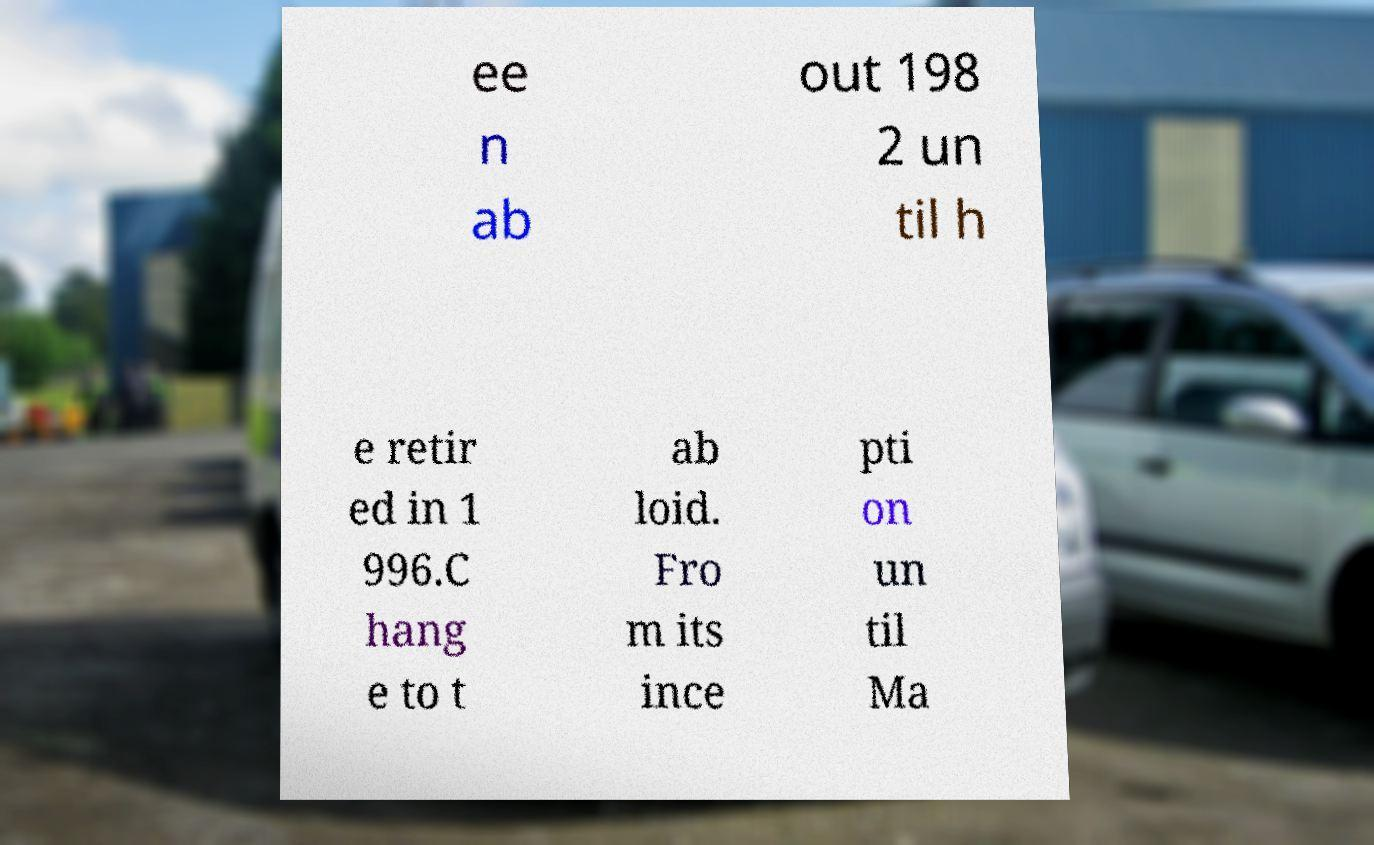Can you accurately transcribe the text from the provided image for me? ee n ab out 198 2 un til h e retir ed in 1 996.C hang e to t ab loid. Fro m its ince pti on un til Ma 